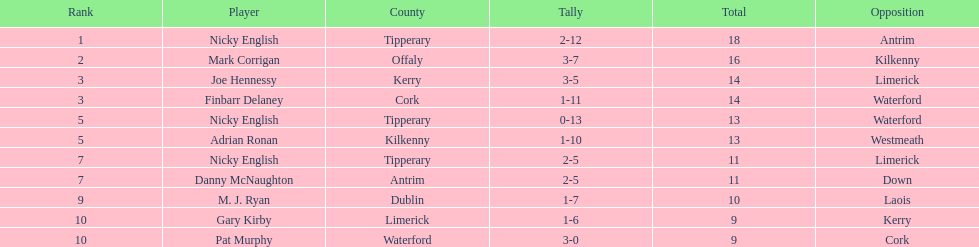What is the first name on the list? Nicky English. 